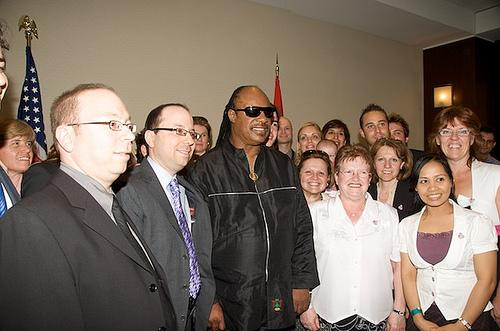In a casual tone, give a brief description of the picture for a friend. Hey! Just saw this cool pic of Stevie Wonder hanging out with a diverse group of people. They are all smiling and look great in their outfits. There's even an American flag in the background! Identify the subject and their appearance in the image if you were introducing them on a talk show. Ladies and gentlemen, please welcome the iconic Stevie Wonder, looking amazing in a fashionable ensemble and his trademark dark glasses, accompanied by a group of stylish smiling guests! Describe the woman with reddish hair and glasses. The woman with reddish hair and glasses is tall, looking at the camera, and wearing a white and purple outfit. What is on top of the American flag in the picture? An eagle is on top of the American flag. Express the scene in terms of the ambiance and setting, as if writing a novel. In a room adorned with the American flag, a lively group of people gathered, their faces radiating happiness. Among them was the legendary Stevie Wonder, stylishly wearing his signature dark glasses. Select a suitable caption for a product advertisement based on the image. "United in Style: Discover the Latest Fashion Trends for Every Occasion - Featuring Stevie Wonder & Friends" Identify the person wearing dark glasses in the image. Stevie Wonder is wearing dark glasses in the image. What emotion does the group in the image seem to be expressing? The group is expressing happiness and joy. Mention an accessory that a woman in the image is wearing on her head. A woman has sunglasses on top of her head. Which two men in the image are wearing regular glasses as part of their attire? Two men in suits are wearing regular glasses in the image. 